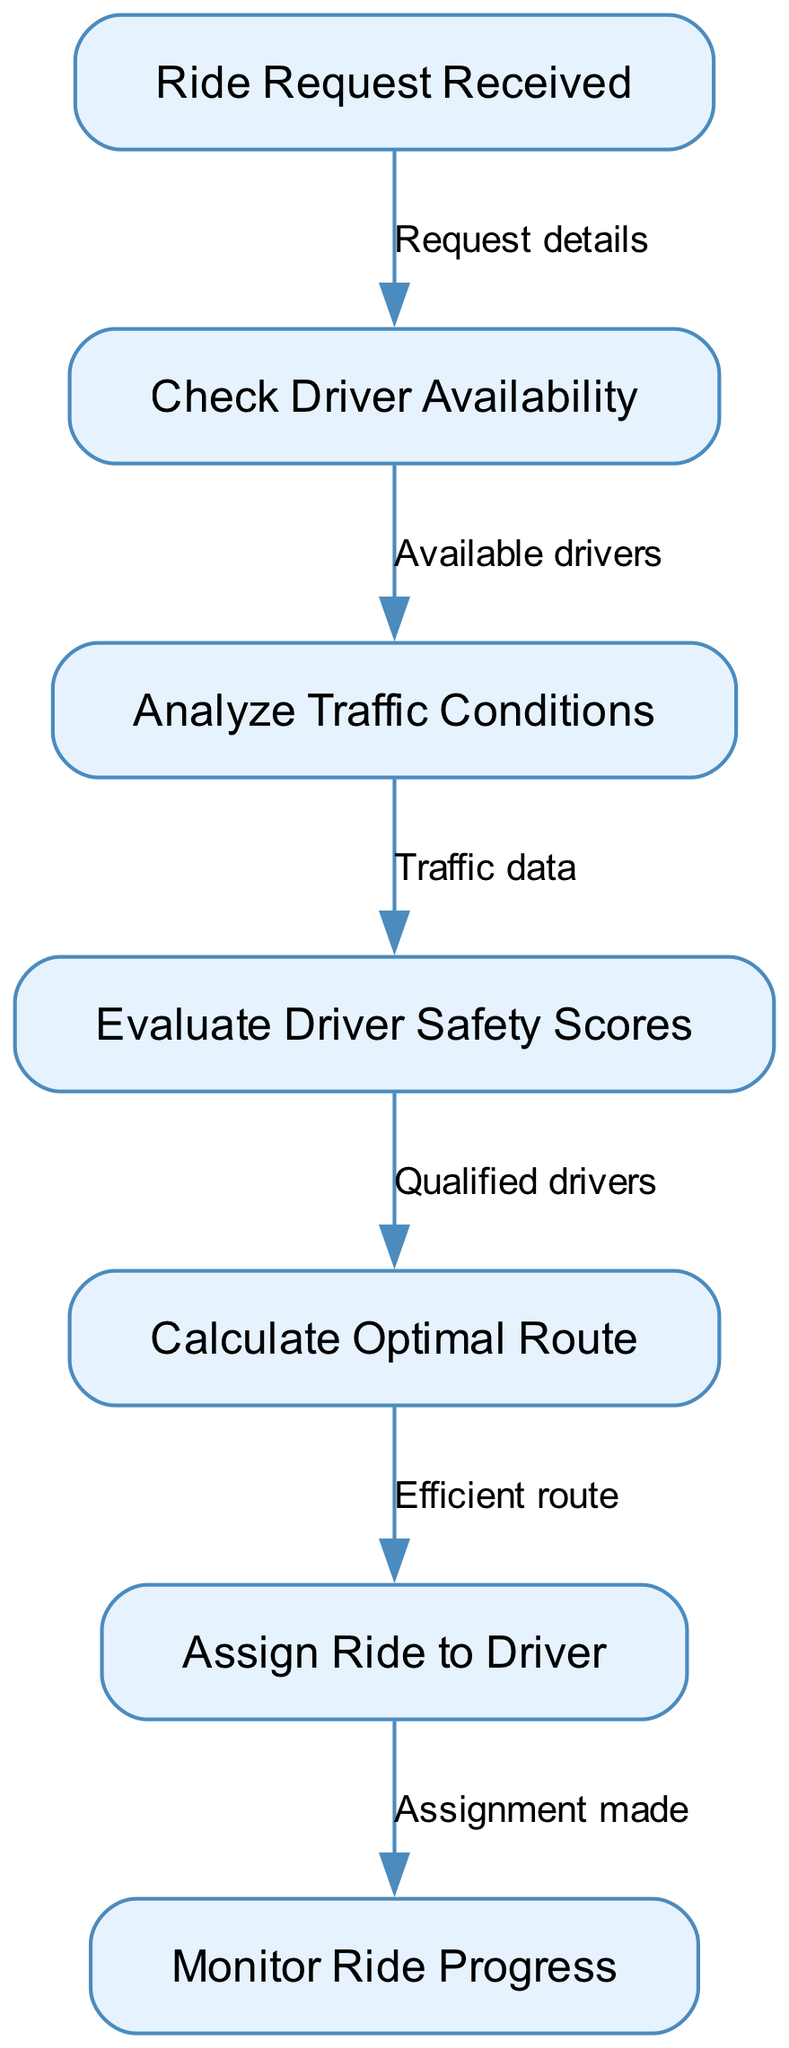What is the first step in the ride assignment process? The first step is represented by the node labeled "Ride Request Received," which indicates the beginning of the algorithm's flow.
Answer: Ride Request Received How many nodes are present in the diagram? By counting the distinct nodes listed (1 to 7), we find that there are a total of 7 nodes in the diagram.
Answer: 7 What is the last step completed in the decision-making process? The final step in the flowchart is "Monitor Ride Progress," which indicates continuous surveillance after the ride assignment has been made.
Answer: Monitor Ride Progress What is the relationship between checking driver availability and analyzing traffic conditions? The relationship is that after checking driver availability, the next step is to analyze traffic conditions, demonstrating a sequential dependency in the decision-making process.
Answer: Available drivers How many edges connect the nodes in the diagram? There are 6 edges in the diagram, each establishing a connection between two nodes, showing the flow from one step to the next.
Answer: 6 Which step evaluates driver safety scores? The step labeled "Evaluate Driver Safety Scores" focuses specifically on assessing the safety of drivers who are available for ride assignments.
Answer: Evaluate Driver Safety Scores What text is associated with the edge connecting analyzing traffic conditions to evaluating driver safety scores? The edge connecting these two nodes is described by the text "Traffic data," indicating that data from traffic conditions influences safety evaluations.
Answer: Traffic data Which node represents the action of assigning a ride to a driver? The node specifically for assigning a ride is labeled "Assign Ride to Driver," indicating the process of pairing a rider with a driver.
Answer: Assign Ride to Driver What comes after calculating the optimal route? The next step after calculating the optimal route is to assign the ride to a driver, marking a progression from route determination to execution of the assignment.
Answer: Assign Ride to Driver 